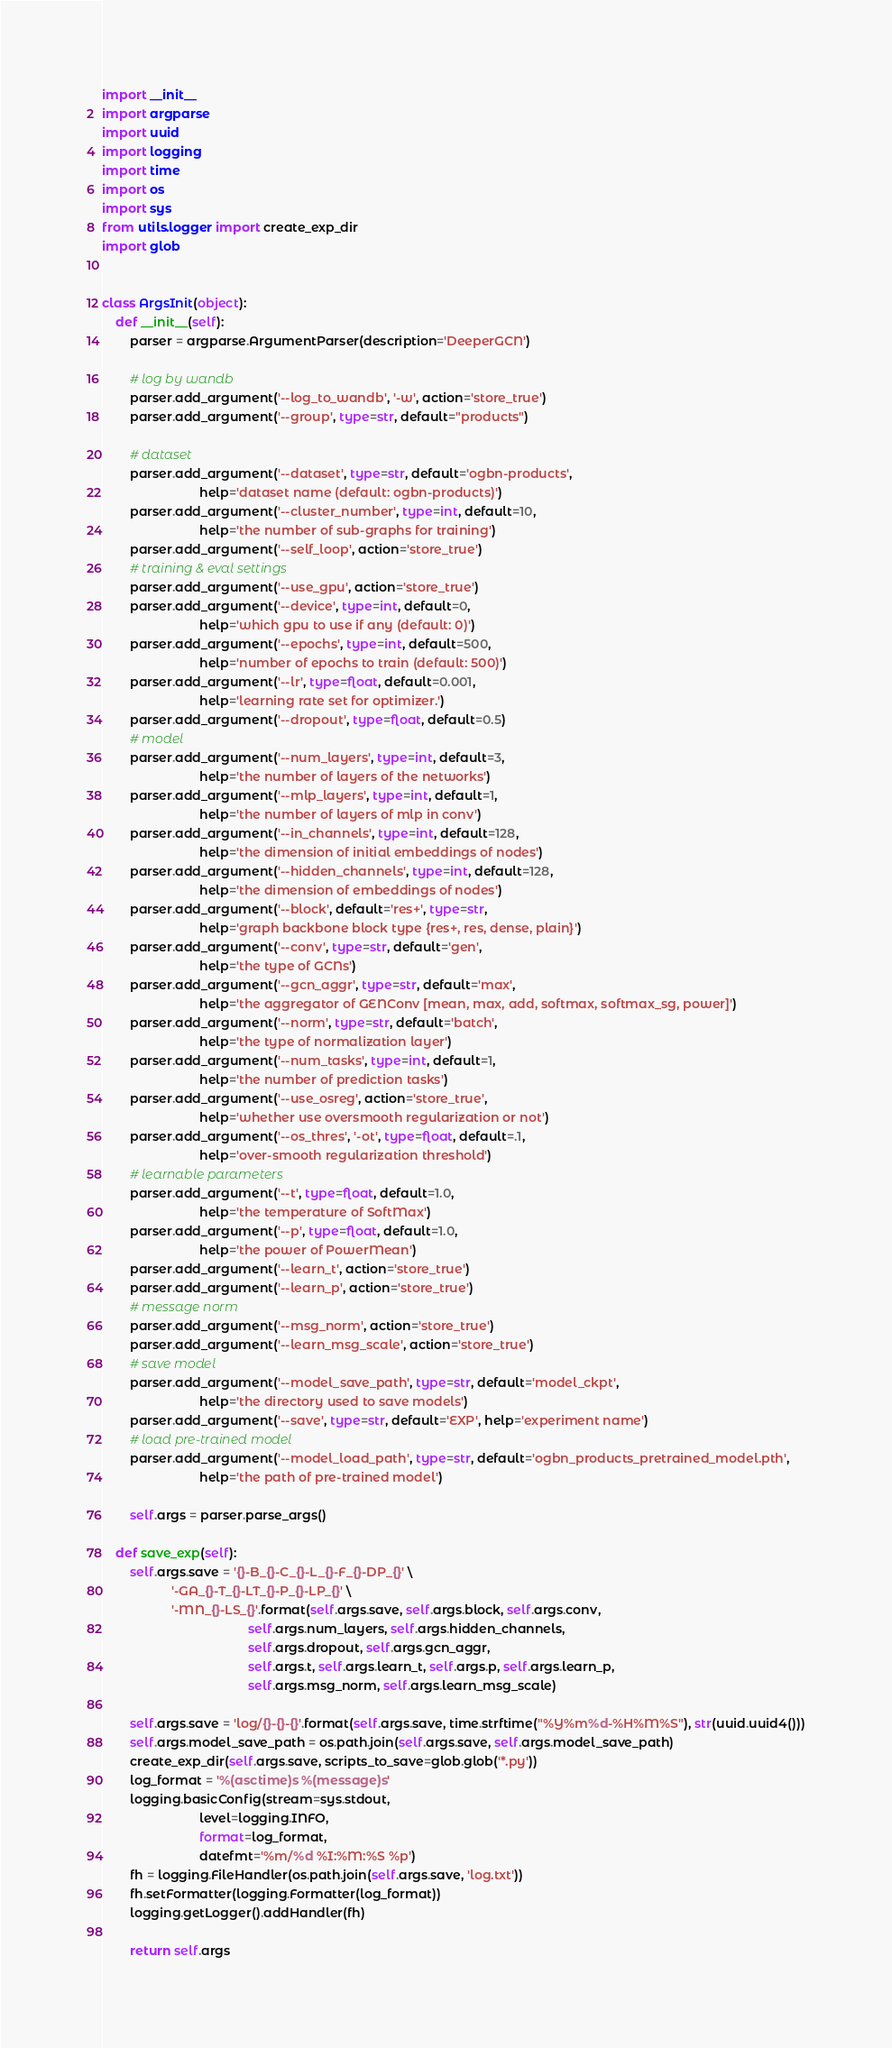Convert code to text. <code><loc_0><loc_0><loc_500><loc_500><_Python_>import __init__
import argparse
import uuid
import logging
import time
import os
import sys
from utils.logger import create_exp_dir
import glob


class ArgsInit(object):
    def __init__(self):
        parser = argparse.ArgumentParser(description='DeeperGCN')

        # log by wandb
        parser.add_argument('--log_to_wandb', '-w', action='store_true')
        parser.add_argument('--group', type=str, default="products")

        # dataset
        parser.add_argument('--dataset', type=str, default='ogbn-products',
                            help='dataset name (default: ogbn-products)')
        parser.add_argument('--cluster_number', type=int, default=10,
                            help='the number of sub-graphs for training')
        parser.add_argument('--self_loop', action='store_true')
        # training & eval settings
        parser.add_argument('--use_gpu', action='store_true')
        parser.add_argument('--device', type=int, default=0,
                            help='which gpu to use if any (default: 0)')
        parser.add_argument('--epochs', type=int, default=500,
                            help='number of epochs to train (default: 500)')
        parser.add_argument('--lr', type=float, default=0.001,
                            help='learning rate set for optimizer.')
        parser.add_argument('--dropout', type=float, default=0.5)
        # model
        parser.add_argument('--num_layers', type=int, default=3,
                            help='the number of layers of the networks')
        parser.add_argument('--mlp_layers', type=int, default=1,
                            help='the number of layers of mlp in conv')
        parser.add_argument('--in_channels', type=int, default=128,
                            help='the dimension of initial embeddings of nodes')
        parser.add_argument('--hidden_channels', type=int, default=128,
                            help='the dimension of embeddings of nodes')
        parser.add_argument('--block', default='res+', type=str,
                            help='graph backbone block type {res+, res, dense, plain}')
        parser.add_argument('--conv', type=str, default='gen',
                            help='the type of GCNs')
        parser.add_argument('--gcn_aggr', type=str, default='max',
                            help='the aggregator of GENConv [mean, max, add, softmax, softmax_sg, power]')
        parser.add_argument('--norm', type=str, default='batch',
                            help='the type of normalization layer')
        parser.add_argument('--num_tasks', type=int, default=1,
                            help='the number of prediction tasks')
        parser.add_argument('--use_osreg', action='store_true',
                            help='whether use oversmooth regularization or not')
        parser.add_argument('--os_thres', '-ot', type=float, default=.1,
                            help='over-smooth regularization threshold')
        # learnable parameters
        parser.add_argument('--t', type=float, default=1.0,
                            help='the temperature of SoftMax')
        parser.add_argument('--p', type=float, default=1.0,
                            help='the power of PowerMean')
        parser.add_argument('--learn_t', action='store_true')
        parser.add_argument('--learn_p', action='store_true')
        # message norm
        parser.add_argument('--msg_norm', action='store_true')
        parser.add_argument('--learn_msg_scale', action='store_true')
        # save model
        parser.add_argument('--model_save_path', type=str, default='model_ckpt',
                            help='the directory used to save models')
        parser.add_argument('--save', type=str, default='EXP', help='experiment name')
        # load pre-trained model
        parser.add_argument('--model_load_path', type=str, default='ogbn_products_pretrained_model.pth',
                            help='the path of pre-trained model')

        self.args = parser.parse_args()

    def save_exp(self):
        self.args.save = '{}-B_{}-C_{}-L_{}-F_{}-DP_{}' \
                    '-GA_{}-T_{}-LT_{}-P_{}-LP_{}' \
                    '-MN_{}-LS_{}'.format(self.args.save, self.args.block, self.args.conv,
                                          self.args.num_layers, self.args.hidden_channels,
                                          self.args.dropout, self.args.gcn_aggr,
                                          self.args.t, self.args.learn_t, self.args.p, self.args.learn_p,
                                          self.args.msg_norm, self.args.learn_msg_scale)

        self.args.save = 'log/{}-{}-{}'.format(self.args.save, time.strftime("%Y%m%d-%H%M%S"), str(uuid.uuid4()))
        self.args.model_save_path = os.path.join(self.args.save, self.args.model_save_path)
        create_exp_dir(self.args.save, scripts_to_save=glob.glob('*.py'))
        log_format = '%(asctime)s %(message)s'
        logging.basicConfig(stream=sys.stdout,
                            level=logging.INFO,
                            format=log_format,
                            datefmt='%m/%d %I:%M:%S %p')
        fh = logging.FileHandler(os.path.join(self.args.save, 'log.txt'))
        fh.setFormatter(logging.Formatter(log_format))
        logging.getLogger().addHandler(fh)

        return self.args
</code> 